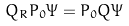Convert formula to latex. <formula><loc_0><loc_0><loc_500><loc_500>Q _ { R } P _ { 0 } \Psi = P _ { 0 } Q \Psi</formula> 